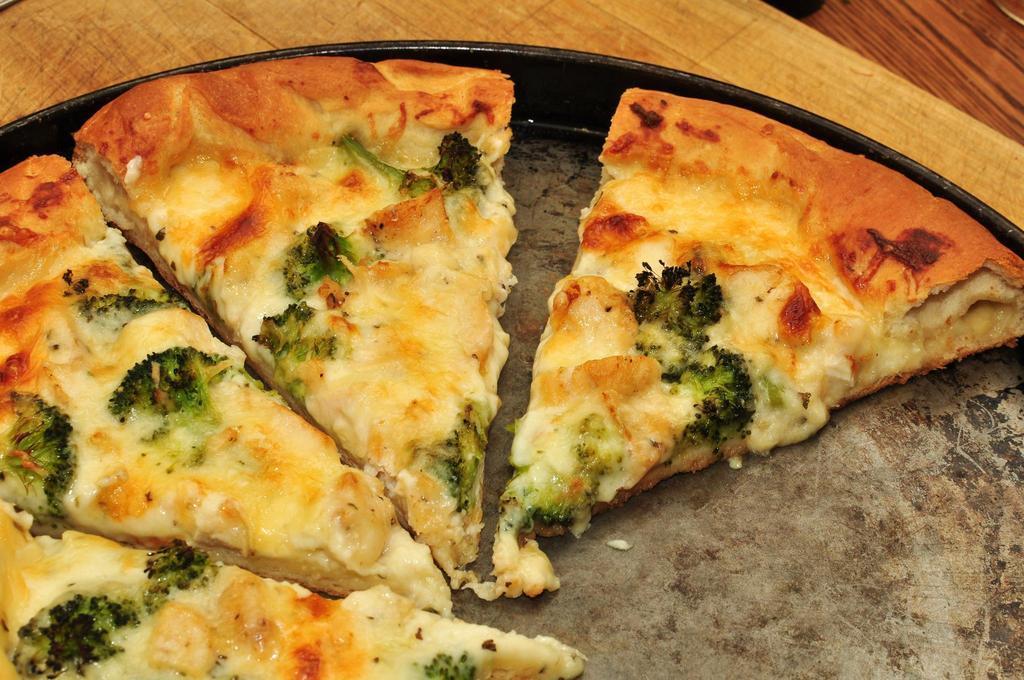Please provide a concise description of this image. In this image on a table there is a plate, on the plate there are slices of pizza. 